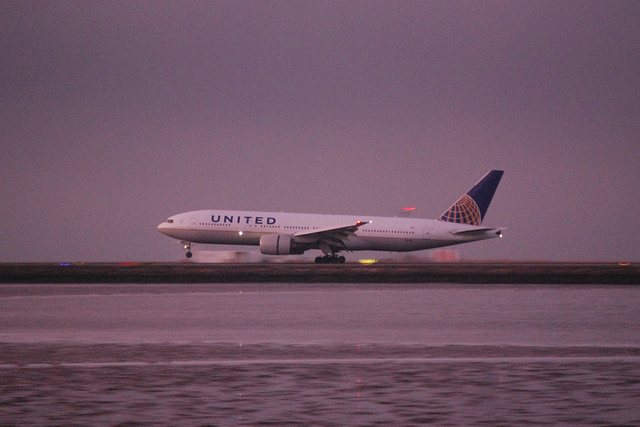Please extract the text content from this image. UNITED 